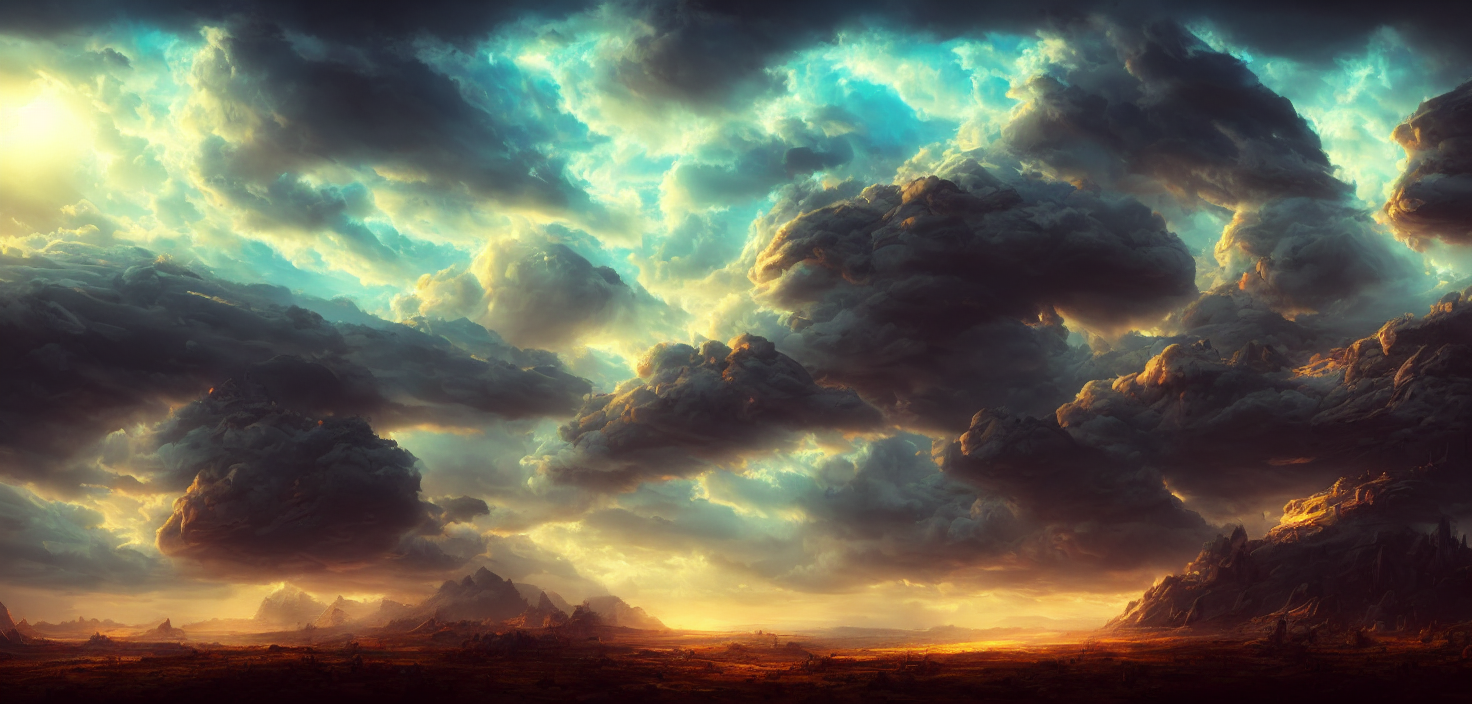Can you describe the general atmosphere and mood this image evokes? The image conveys a sense of awe and majesty, perhaps mixed with a hint of foreboding. The interplay of light and shadow, combined with the colossal cloud formations and vast landscape, suggest a storyline filled with adventure and the sublime beauty of nature. Given the dramatic sky, what kind of weather might be predicted? The towering clouds and the way light pierces through them might indicate the approach of a storm, potentially bringing rain or thunderstorms. The scene captures nature just before a significant weather event, imbued with anticipation. 